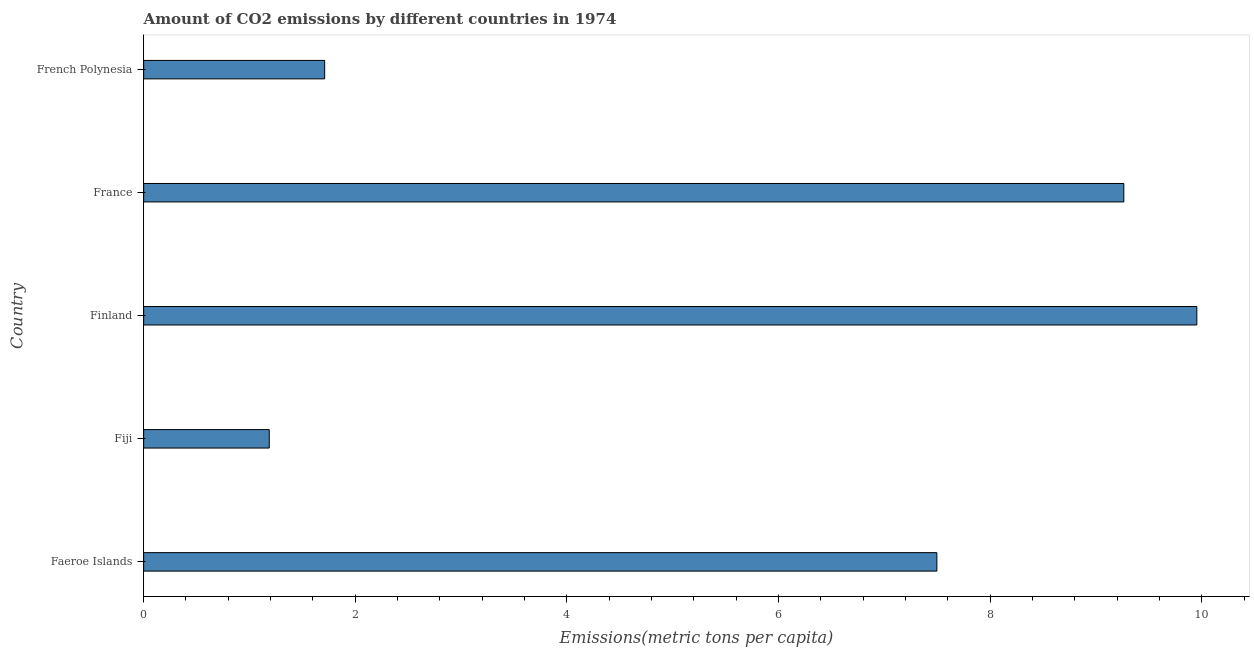What is the title of the graph?
Provide a succinct answer. Amount of CO2 emissions by different countries in 1974. What is the label or title of the X-axis?
Make the answer very short. Emissions(metric tons per capita). What is the label or title of the Y-axis?
Your answer should be very brief. Country. What is the amount of co2 emissions in Finland?
Offer a terse response. 9.95. Across all countries, what is the maximum amount of co2 emissions?
Your response must be concise. 9.95. Across all countries, what is the minimum amount of co2 emissions?
Provide a succinct answer. 1.19. In which country was the amount of co2 emissions minimum?
Make the answer very short. Fiji. What is the sum of the amount of co2 emissions?
Make the answer very short. 29.61. What is the difference between the amount of co2 emissions in Fiji and France?
Your answer should be very brief. -8.07. What is the average amount of co2 emissions per country?
Your response must be concise. 5.92. What is the median amount of co2 emissions?
Keep it short and to the point. 7.5. What is the ratio of the amount of co2 emissions in Fiji to that in French Polynesia?
Ensure brevity in your answer.  0.69. Is the amount of co2 emissions in Faeroe Islands less than that in French Polynesia?
Offer a terse response. No. What is the difference between the highest and the second highest amount of co2 emissions?
Provide a succinct answer. 0.69. What is the difference between the highest and the lowest amount of co2 emissions?
Your response must be concise. 8.77. In how many countries, is the amount of co2 emissions greater than the average amount of co2 emissions taken over all countries?
Give a very brief answer. 3. How many bars are there?
Provide a short and direct response. 5. Are all the bars in the graph horizontal?
Provide a short and direct response. Yes. Are the values on the major ticks of X-axis written in scientific E-notation?
Your response must be concise. No. What is the Emissions(metric tons per capita) in Faeroe Islands?
Offer a very short reply. 7.5. What is the Emissions(metric tons per capita) in Fiji?
Provide a short and direct response. 1.19. What is the Emissions(metric tons per capita) of Finland?
Your answer should be compact. 9.95. What is the Emissions(metric tons per capita) of France?
Keep it short and to the point. 9.26. What is the Emissions(metric tons per capita) of French Polynesia?
Provide a short and direct response. 1.71. What is the difference between the Emissions(metric tons per capita) in Faeroe Islands and Fiji?
Give a very brief answer. 6.31. What is the difference between the Emissions(metric tons per capita) in Faeroe Islands and Finland?
Your answer should be compact. -2.46. What is the difference between the Emissions(metric tons per capita) in Faeroe Islands and France?
Make the answer very short. -1.77. What is the difference between the Emissions(metric tons per capita) in Faeroe Islands and French Polynesia?
Your response must be concise. 5.79. What is the difference between the Emissions(metric tons per capita) in Fiji and Finland?
Offer a very short reply. -8.77. What is the difference between the Emissions(metric tons per capita) in Fiji and France?
Your answer should be compact. -8.08. What is the difference between the Emissions(metric tons per capita) in Fiji and French Polynesia?
Your answer should be compact. -0.52. What is the difference between the Emissions(metric tons per capita) in Finland and France?
Provide a short and direct response. 0.69. What is the difference between the Emissions(metric tons per capita) in Finland and French Polynesia?
Your response must be concise. 8.24. What is the difference between the Emissions(metric tons per capita) in France and French Polynesia?
Offer a very short reply. 7.55. What is the ratio of the Emissions(metric tons per capita) in Faeroe Islands to that in Fiji?
Offer a very short reply. 6.32. What is the ratio of the Emissions(metric tons per capita) in Faeroe Islands to that in Finland?
Make the answer very short. 0.75. What is the ratio of the Emissions(metric tons per capita) in Faeroe Islands to that in France?
Ensure brevity in your answer.  0.81. What is the ratio of the Emissions(metric tons per capita) in Faeroe Islands to that in French Polynesia?
Ensure brevity in your answer.  4.38. What is the ratio of the Emissions(metric tons per capita) in Fiji to that in Finland?
Keep it short and to the point. 0.12. What is the ratio of the Emissions(metric tons per capita) in Fiji to that in France?
Make the answer very short. 0.13. What is the ratio of the Emissions(metric tons per capita) in Fiji to that in French Polynesia?
Ensure brevity in your answer.  0.69. What is the ratio of the Emissions(metric tons per capita) in Finland to that in France?
Your answer should be compact. 1.07. What is the ratio of the Emissions(metric tons per capita) in Finland to that in French Polynesia?
Provide a short and direct response. 5.82. What is the ratio of the Emissions(metric tons per capita) in France to that in French Polynesia?
Offer a very short reply. 5.42. 